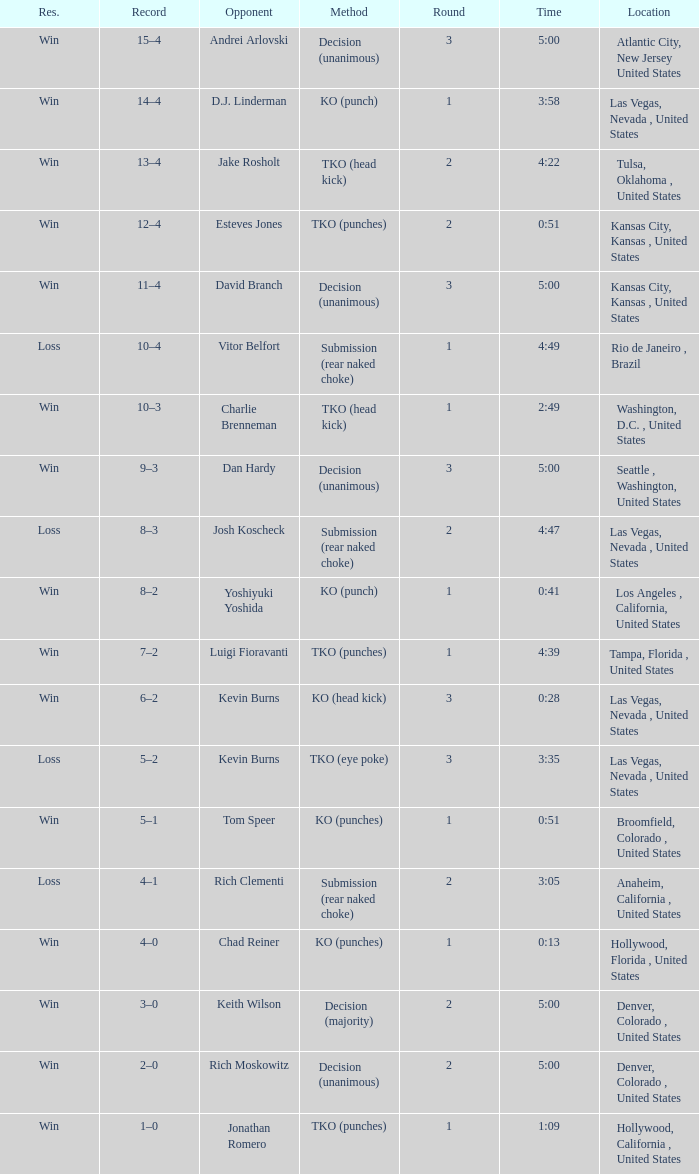Which record has a timing of 0:13? 4–0. 